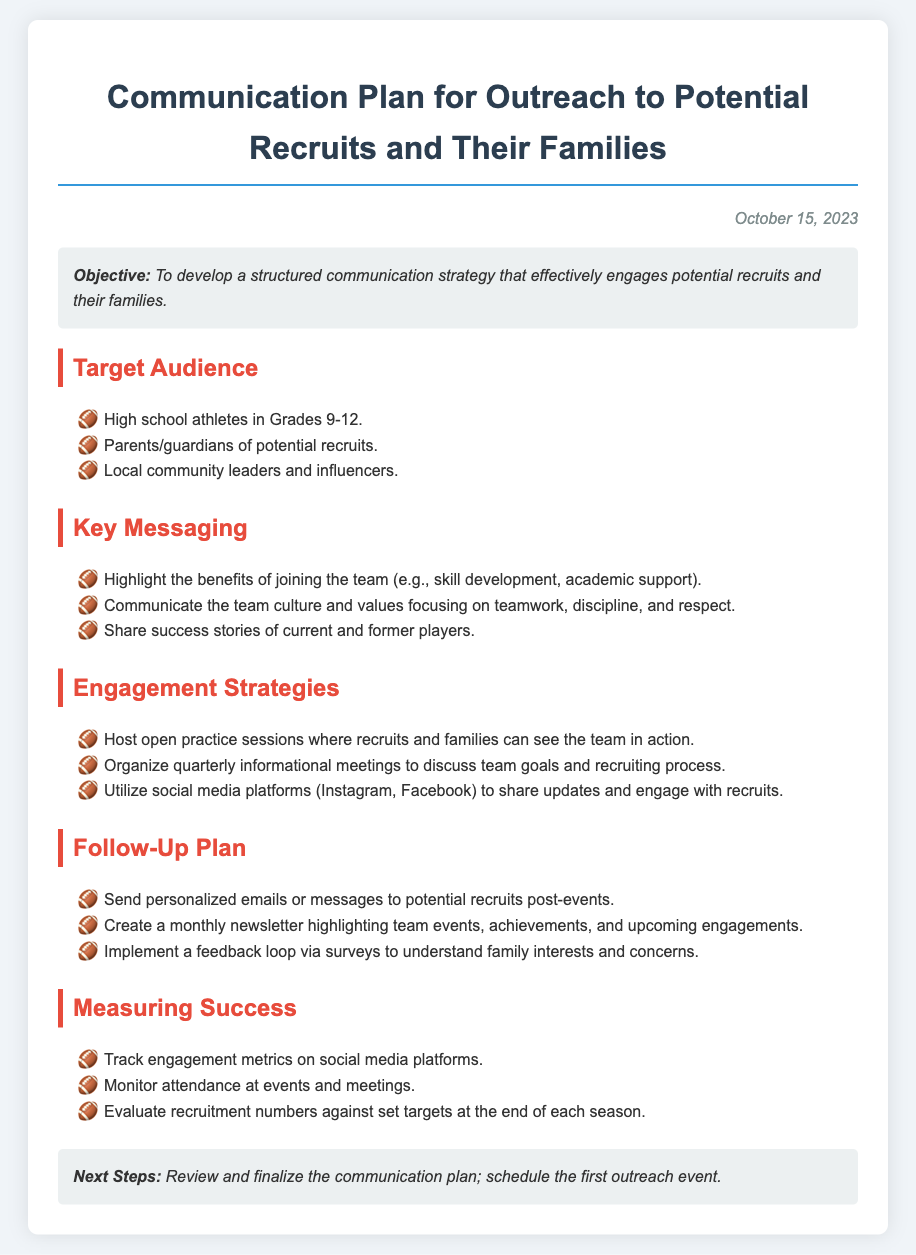what is the date of the communication plan? The date is mentioned at the top of the document, indicating when it was created.
Answer: October 15, 2023 who is the target audience? The document lists specific groups that the communication plan is aimed at.
Answer: High school athletes in Grades 9-12, Parents/guardians of potential recruits, Local community leaders and influencers what are the key messaging points? The document outlines important points that should be communicated to the target audience throughout the outreach.
Answer: Highlight benefits, Communicate team culture, Share success stories how many engagement strategies are listed? The number of engagement strategies provided in the document can be counted directly from the section.
Answer: Three what does the follow-up plan include? The document specifies actions to be taken after initial outreach to maintain engagement.
Answer: Personalized emails, Monthly newsletter, Feedback loop via surveys what is the overall objective of the plan? The first section of the document states the main goal of the communication strategy.
Answer: Develop a structured communication strategy how will success be measured? The document includes a section that describes how the effectiveness of the communication plan will be evaluated.
Answer: Track engagement metrics, Monitor attendance, Evaluate recruitment numbers what is the next step outlined in the plan? The closing section of the document provides the immediate action required after the plan is reviewed.
Answer: Review and finalize the communication plan what type of meetings are planned for engagement? The document describes specific types of meetings as part of the engagement strategies.
Answer: Informational meetings 